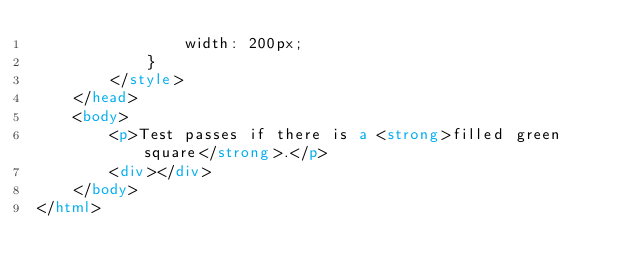Convert code to text. <code><loc_0><loc_0><loc_500><loc_500><_HTML_>                width: 200px;
            }
        </style>
    </head>
    <body>
        <p>Test passes if there is a <strong>filled green square</strong>.</p>
        <div></div>
    </body>
</html>
</code> 